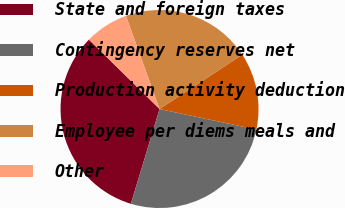Convert chart to OTSL. <chart><loc_0><loc_0><loc_500><loc_500><pie_chart><fcel>State and foreign taxes<fcel>Contingency reserves net<fcel>Production activity deduction<fcel>Employee per diems meals and<fcel>Other<nl><fcel>32.69%<fcel>26.35%<fcel>12.57%<fcel>21.26%<fcel>7.13%<nl></chart> 